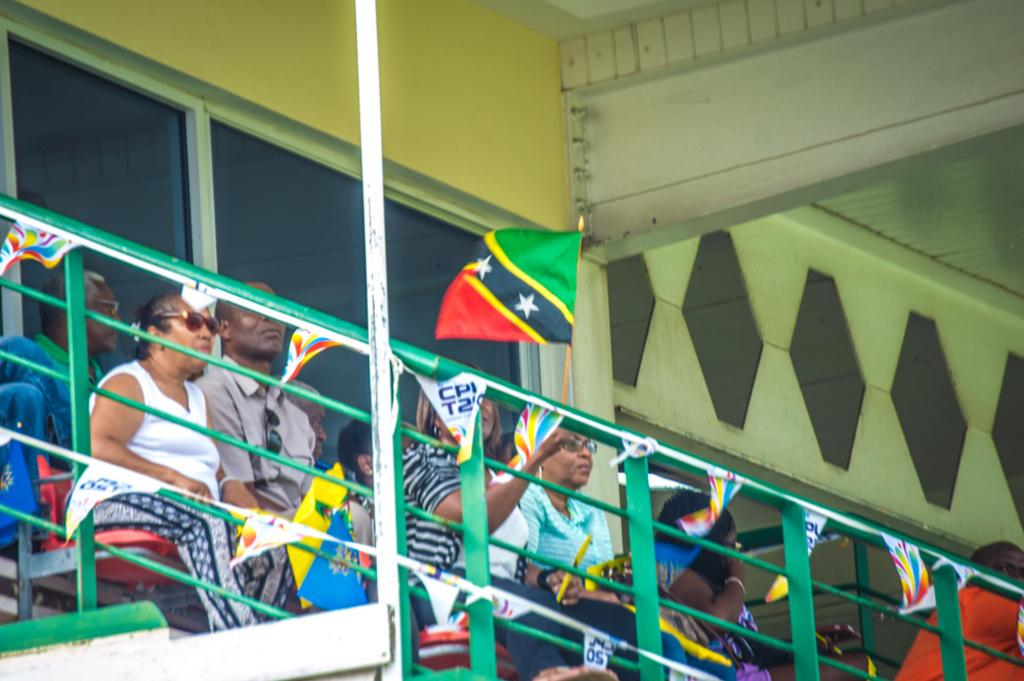<image>
Create a compact narrative representing the image presented. a sign that has the letters T2 on it 